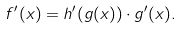Convert formula to latex. <formula><loc_0><loc_0><loc_500><loc_500>f ^ { \prime } ( x ) = h ^ { \prime } ( g ( x ) ) \cdot g ^ { \prime } ( x ) .</formula> 